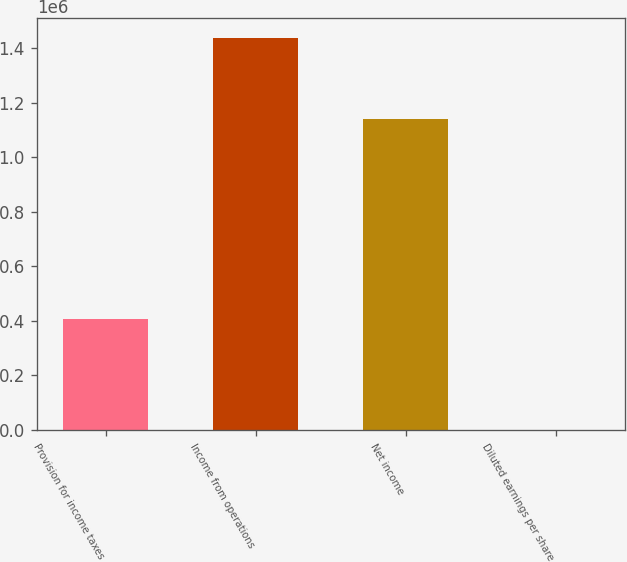<chart> <loc_0><loc_0><loc_500><loc_500><bar_chart><fcel>Provision for income taxes<fcel>Income from operations<fcel>Net income<fcel>Diluted earnings per share<nl><fcel>405947<fcel>1.43843e+06<fcel>1.14111e+06<fcel>0.8<nl></chart> 